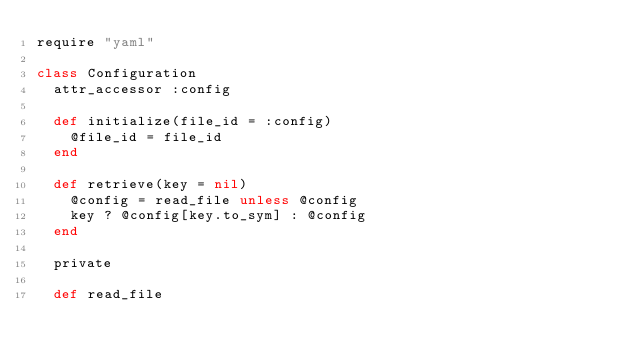<code> <loc_0><loc_0><loc_500><loc_500><_Ruby_>require "yaml"

class Configuration
  attr_accessor :config

  def initialize(file_id = :config)
    @file_id = file_id
  end

  def retrieve(key = nil)
    @config = read_file unless @config
    key ? @config[key.to_sym] : @config
  end

  private

  def read_file</code> 